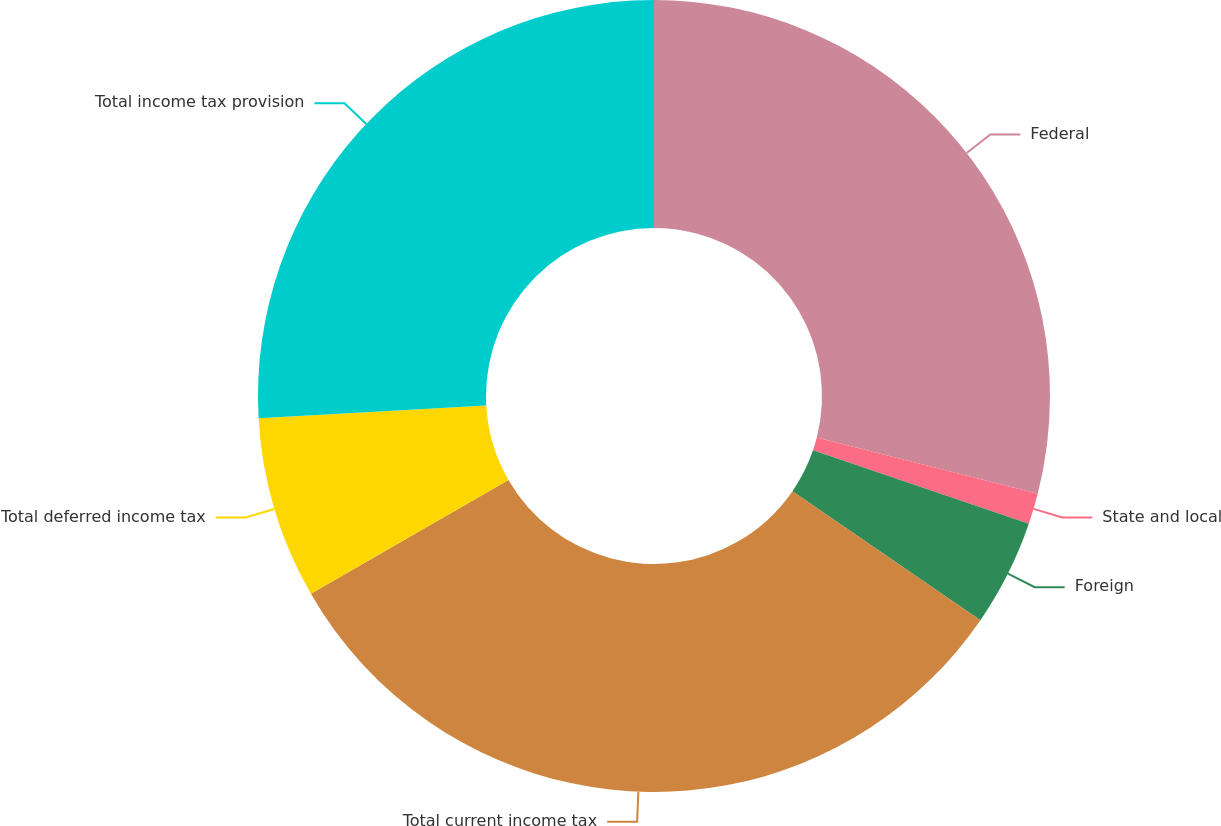<chart> <loc_0><loc_0><loc_500><loc_500><pie_chart><fcel>Federal<fcel>State and local<fcel>Foreign<fcel>Total current income tax<fcel>Total deferred income tax<fcel>Total income tax provision<nl><fcel>28.97%<fcel>1.26%<fcel>4.35%<fcel>32.1%<fcel>7.43%<fcel>25.89%<nl></chart> 